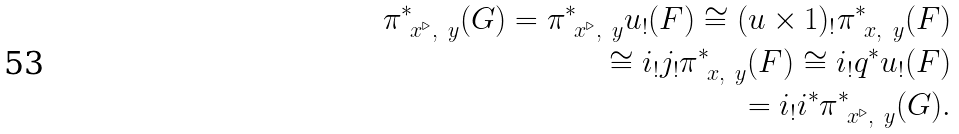Convert formula to latex. <formula><loc_0><loc_0><loc_500><loc_500>\pi _ { \ x ^ { \triangleright } , \ y } ^ { * } ( G ) = \pi _ { \ x ^ { \triangleright } , \ y } ^ { * } u _ { ! } ( F ) \cong ( u \times 1 ) _ { ! } \pi _ { \ x , \ y } ^ { * } ( F ) \\ \cong i _ { ! } j _ { ! } \pi _ { \ x , \ y } ^ { * } ( F ) \cong i _ { ! } q ^ { * } u _ { ! } ( F ) \\ = i _ { ! } i ^ { * } \pi ^ { * } _ { \ x ^ { \triangleright } , \ y } ( G ) .</formula> 